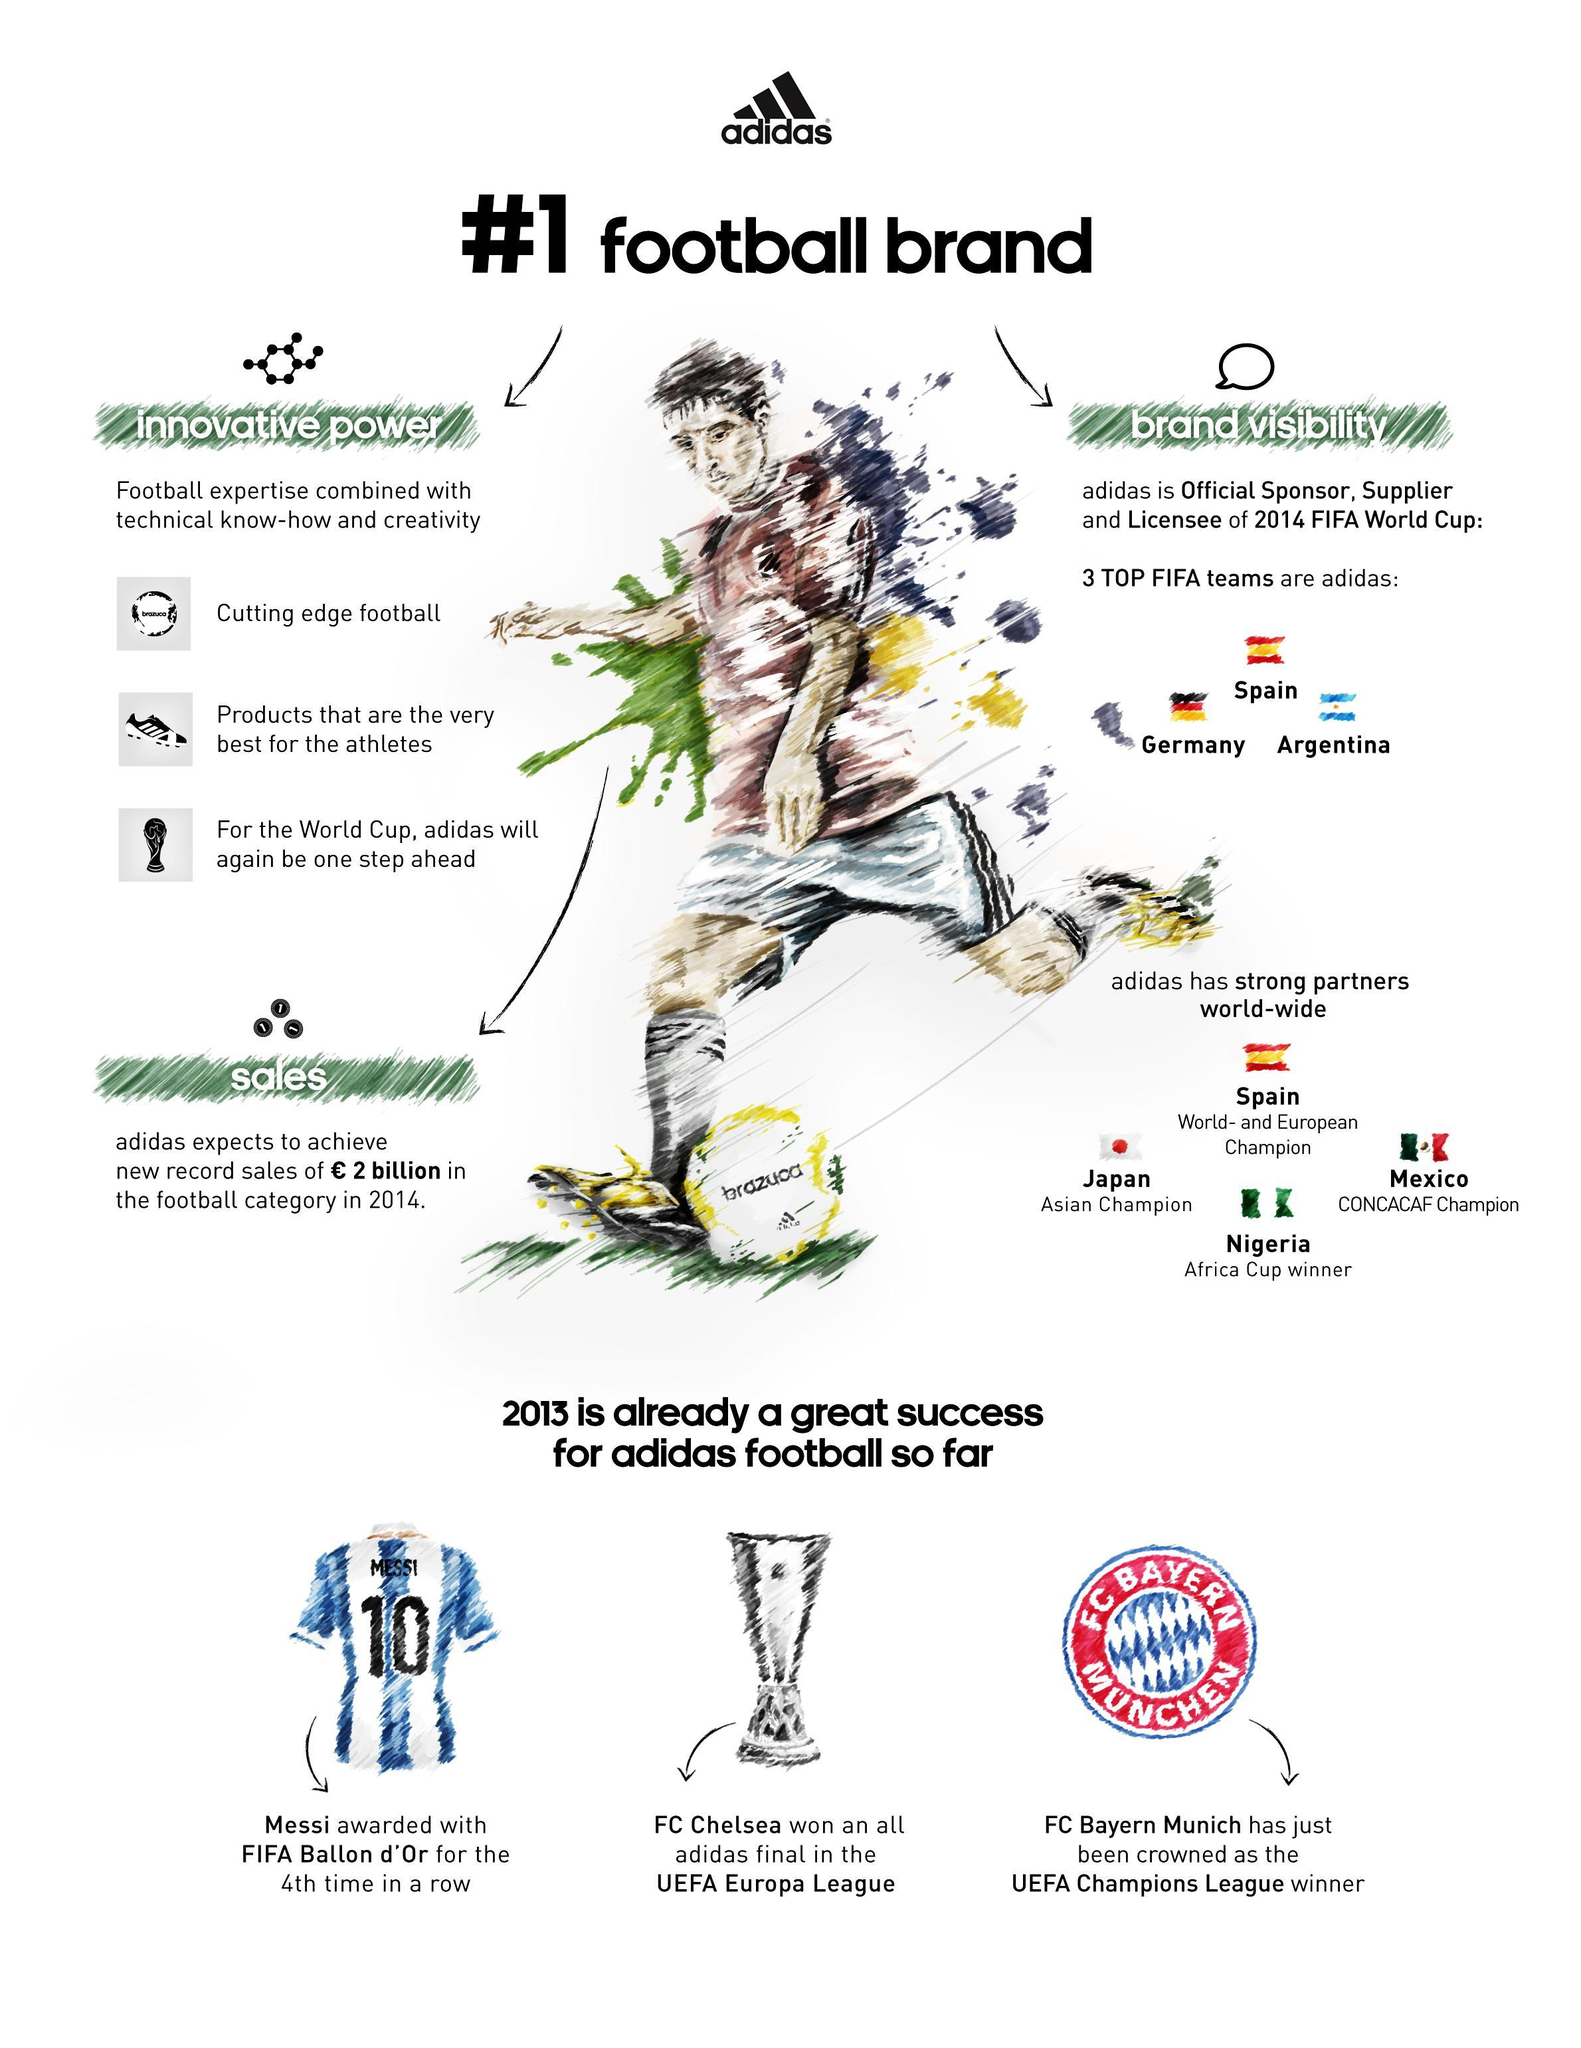Which team is Africa Cup winner?
Answer the question with a short phrase. Nigeria How much sales (in Euros) expected in 2014 by adidas? 2 billion In 2013 who got FIFA Ballon d'Or award for the 4th time in a row? Messi Which team is CONCACAF Champion? Mexico Which are the top 3 FIFA teams? Spain, Germany, Argentina Which team won the 2013 UEFA Europa League Final? FC Chelsea Which team is Asian champion? Japan Which team is world and European champion? Spain Who is Official sponsor, supplier and Licensee of 2014 FIFA world cup? adidas Who was crowned UEFA Champions League winner in 2013? FC Bayern Munich 